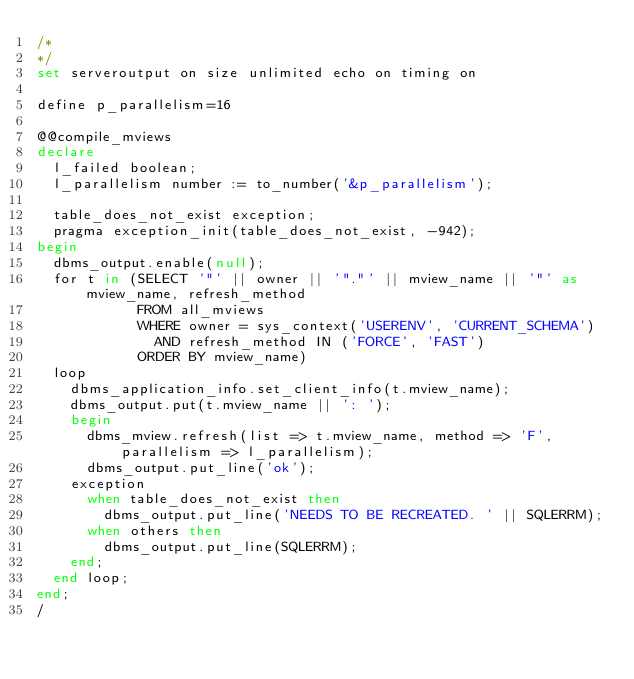<code> <loc_0><loc_0><loc_500><loc_500><_SQL_>/*
*/
set serveroutput on size unlimited echo on timing on

define p_parallelism=16

@@compile_mviews
declare
  l_failed boolean;
  l_parallelism number := to_number('&p_parallelism');

  table_does_not_exist exception;
  pragma exception_init(table_does_not_exist, -942);
begin
  dbms_output.enable(null);
  for t in (SELECT '"' || owner || '"."' || mview_name || '"' as mview_name, refresh_method
            FROM all_mviews
            WHERE owner = sys_context('USERENV', 'CURRENT_SCHEMA')
              AND refresh_method IN ('FORCE', 'FAST')
            ORDER BY mview_name)
  loop
    dbms_application_info.set_client_info(t.mview_name);
    dbms_output.put(t.mview_name || ': ');
    begin
      dbms_mview.refresh(list => t.mview_name, method => 'F', parallelism => l_parallelism);
      dbms_output.put_line('ok');
    exception
      when table_does_not_exist then
        dbms_output.put_line('NEEDS TO BE RECREATED. ' || SQLERRM);
      when others then
        dbms_output.put_line(SQLERRM);
    end;
  end loop;
end;
/
</code> 